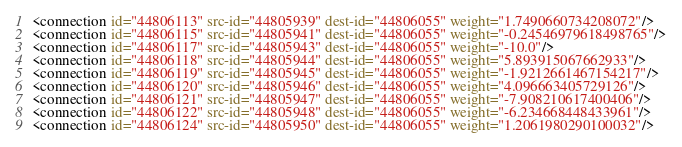<code> <loc_0><loc_0><loc_500><loc_500><_XML_><connection id="44806113" src-id="44805939" dest-id="44806055" weight="1.7490660734208072"/>
<connection id="44806115" src-id="44805941" dest-id="44806055" weight="-0.24546979618498765"/>
<connection id="44806117" src-id="44805943" dest-id="44806055" weight="-10.0"/>
<connection id="44806118" src-id="44805944" dest-id="44806055" weight="5.893915067662933"/>
<connection id="44806119" src-id="44805945" dest-id="44806055" weight="-1.9212661467154217"/>
<connection id="44806120" src-id="44805946" dest-id="44806055" weight="4.096663405729126"/>
<connection id="44806121" src-id="44805947" dest-id="44806055" weight="-7.908210617400406"/>
<connection id="44806122" src-id="44805948" dest-id="44806055" weight="-6.234668448433961"/>
<connection id="44806124" src-id="44805950" dest-id="44806055" weight="1.2061980290100032"/></code> 